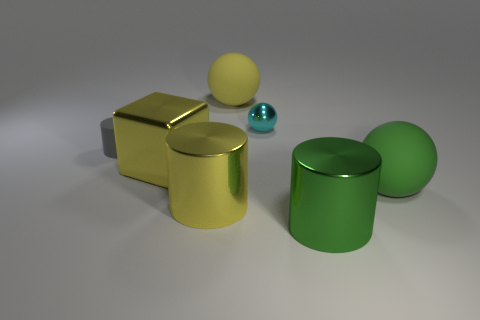Is the size of the sphere in front of the tiny cyan thing the same as the matte sphere behind the tiny cyan metal object?
Provide a short and direct response. Yes. There is a big metal object to the right of the big sphere that is behind the gray matte thing; what is its shape?
Provide a short and direct response. Cylinder. There is a green metal thing; what number of cyan shiny objects are in front of it?
Provide a short and direct response. 0. There is a cube that is made of the same material as the tiny cyan thing; what is its color?
Provide a succinct answer. Yellow. There is a cyan metallic ball; is it the same size as the yellow sphere that is on the left side of the cyan sphere?
Your answer should be compact. No. There is a matte ball in front of the large sphere behind the gray matte thing that is in front of the cyan ball; what size is it?
Make the answer very short. Large. How many matte objects are either green balls or yellow things?
Your response must be concise. 2. The cylinder that is right of the small cyan ball is what color?
Make the answer very short. Green. There is a green rubber object that is the same size as the block; what is its shape?
Keep it short and to the point. Sphere. There is a rubber cylinder; is its color the same as the rubber thing right of the tiny cyan ball?
Your answer should be very brief. No. 